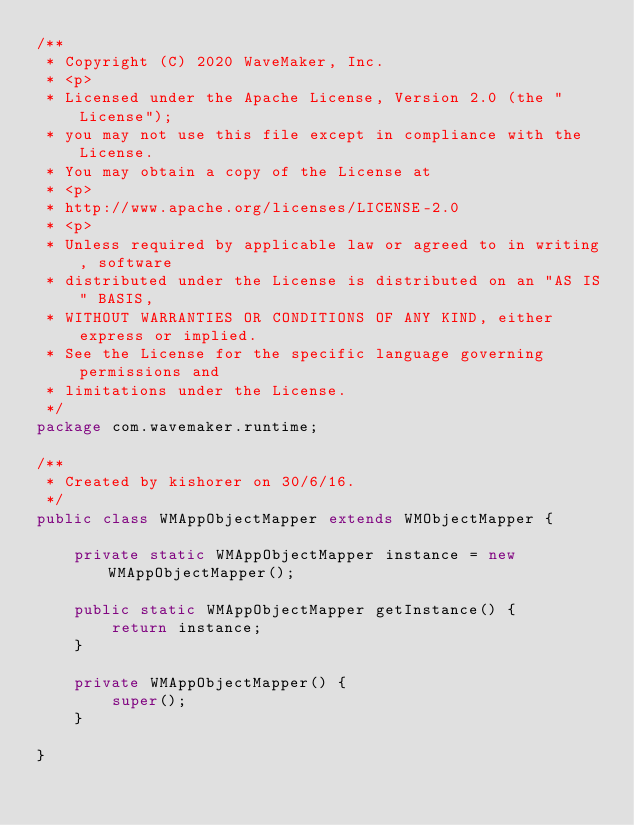<code> <loc_0><loc_0><loc_500><loc_500><_Java_>/**
 * Copyright (C) 2020 WaveMaker, Inc.
 * <p>
 * Licensed under the Apache License, Version 2.0 (the "License");
 * you may not use this file except in compliance with the License.
 * You may obtain a copy of the License at
 * <p>
 * http://www.apache.org/licenses/LICENSE-2.0
 * <p>
 * Unless required by applicable law or agreed to in writing, software
 * distributed under the License is distributed on an "AS IS" BASIS,
 * WITHOUT WARRANTIES OR CONDITIONS OF ANY KIND, either express or implied.
 * See the License for the specific language governing permissions and
 * limitations under the License.
 */
package com.wavemaker.runtime;

/**
 * Created by kishorer on 30/6/16.
 */
public class WMAppObjectMapper extends WMObjectMapper {

    private static WMAppObjectMapper instance = new WMAppObjectMapper();

    public static WMAppObjectMapper getInstance() {
        return instance;
    }

    private WMAppObjectMapper() {
        super();
    }

}
</code> 